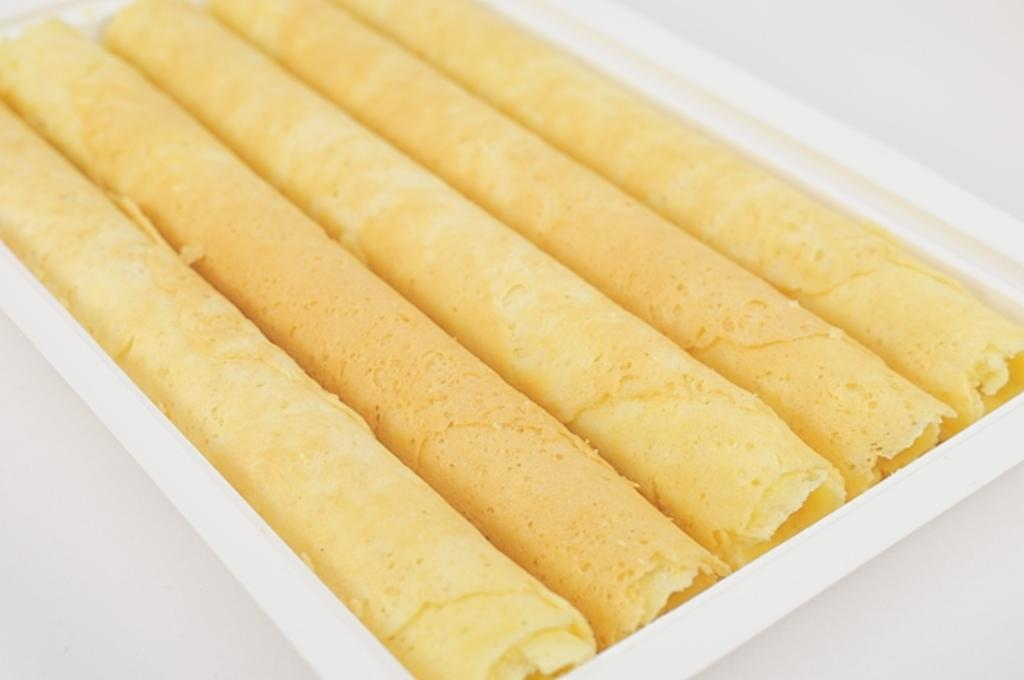What type of items can be seen in the image? There are food items in the image. How are the food items contained or organized in the image? The food items are in a white color box. What type of rhythm can be heard coming from the food items in the image? There is no rhythm associated with the food items in the image, as they are inanimate objects. 